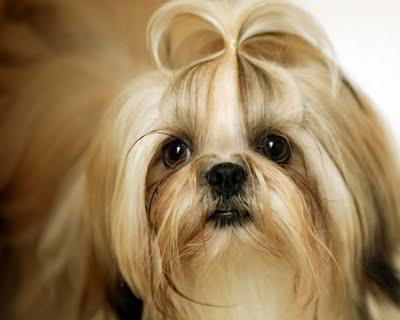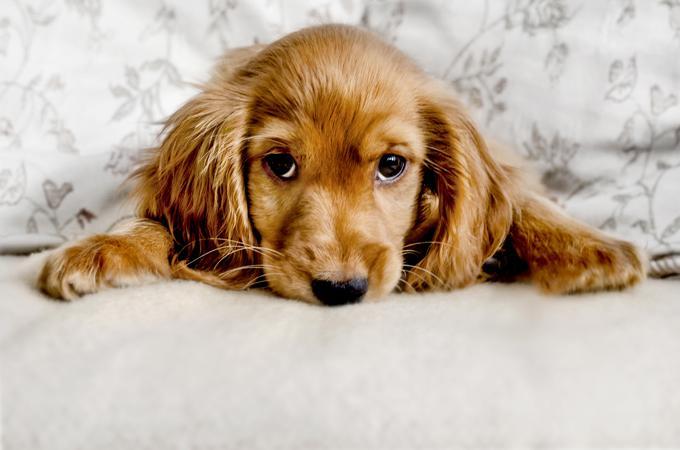The first image is the image on the left, the second image is the image on the right. Considering the images on both sides, is "The dog in the left image has a hair decoration." valid? Answer yes or no. Yes. 